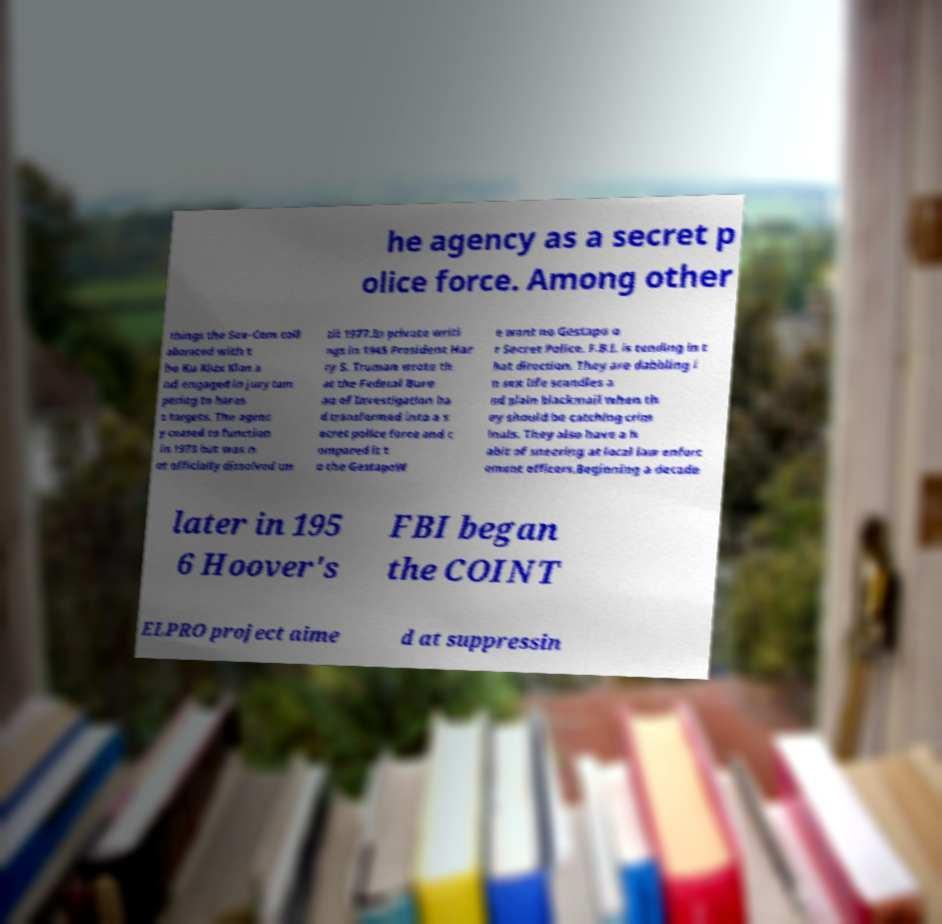I need the written content from this picture converted into text. Can you do that? he agency as a secret p olice force. Among other things the Sov-Com coll aborated with t he Ku Klux Klan a nd engaged in jury tam pering to haras s targets. The agenc y ceased to function in 1973 but was n ot officially dissolved un til 1977.In private writi ngs in 1945 President Har ry S. Truman wrote th at the Federal Bure au of Investigation ha d transformed into a s ecret police force and c ompared it t o the GestapoW e want no Gestapo o r Secret Police. F.B.I. is tending in t hat direction. They are dabbling i n sex life scandles a nd plain blackmail when th ey should be catching crim inals. They also have a h abit of sneering at local law enforc ement officers.Beginning a decade later in 195 6 Hoover's FBI began the COINT ELPRO project aime d at suppressin 